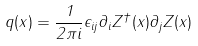Convert formula to latex. <formula><loc_0><loc_0><loc_500><loc_500>q ( x ) = \frac { 1 } { 2 \pi i } \epsilon _ { i j } \partial _ { i } Z ^ { \dagger } ( x ) \partial _ { j } Z ( x )</formula> 